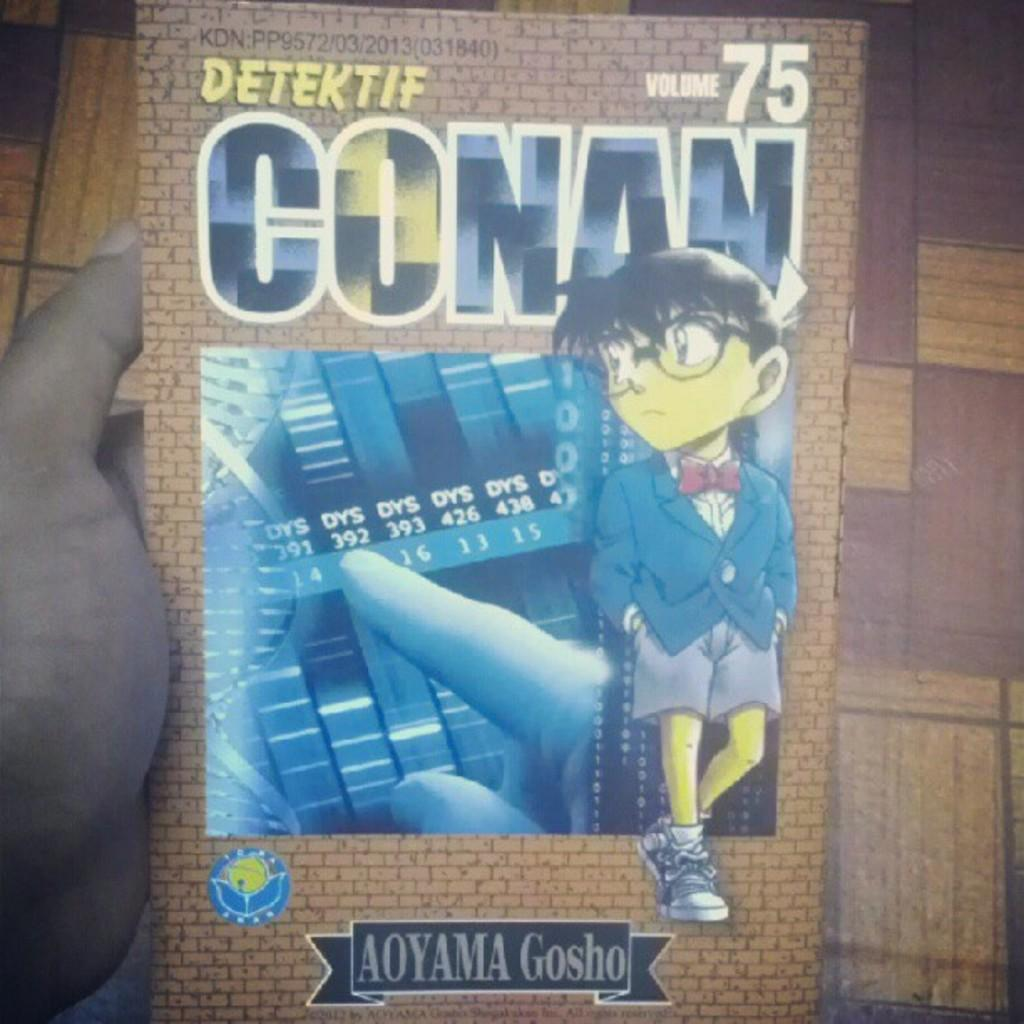Provide a one-sentence caption for the provided image. Poster for an anime named Detektif Conan by Aoyama Gosho. 